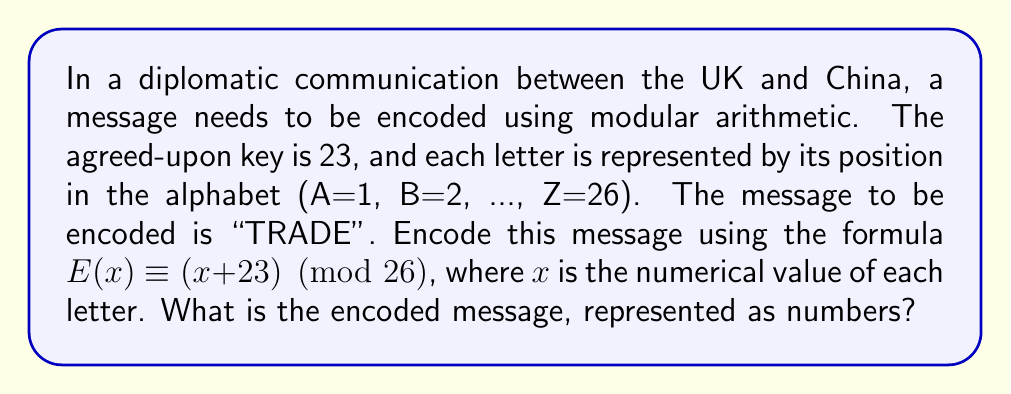Give your solution to this math problem. Let's encode the message "TRADE" step by step:

1) First, convert each letter to its numerical value:
   T = 20, R = 18, A = 1, D = 4, E = 5

2) Now, apply the encoding formula $E(x) \equiv (x + 23) \pmod{26}$ to each number:

   For T (20): $E(20) \equiv (20 + 23) \pmod{26} \equiv 43 \pmod{26} \equiv 17$
   For R (18): $E(18) \equiv (18 + 23) \pmod{26} \equiv 41 \pmod{26} \equiv 15$
   For A (1):  $E(1) \equiv (1 + 23) \pmod{26} \equiv 24 \pmod{26} \equiv 24$
   For D (4):  $E(4) \equiv (4 + 23) \pmod{26} \equiv 27 \pmod{26} \equiv 1$
   For E (5):  $E(5) \equiv (5 + 23) \pmod{26} \equiv 28 \pmod{26} \equiv 2$

3) The encoded message is thus represented by the numbers: 17 15 24 1 2
Answer: 17 15 24 1 2 